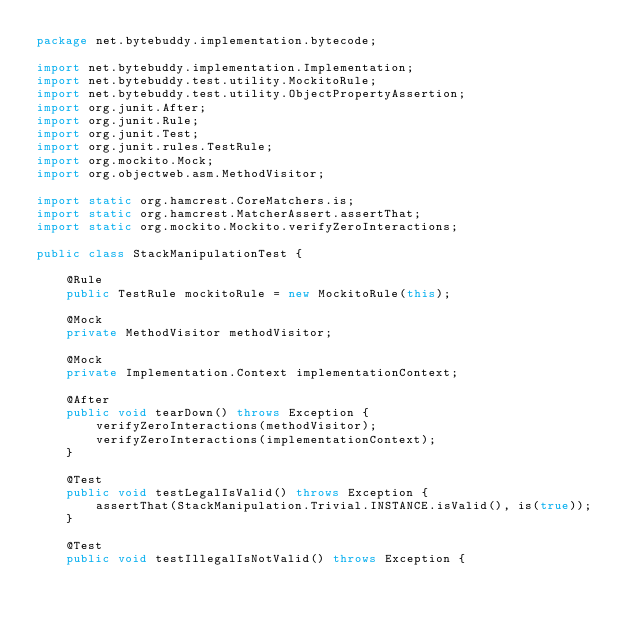<code> <loc_0><loc_0><loc_500><loc_500><_Java_>package net.bytebuddy.implementation.bytecode;

import net.bytebuddy.implementation.Implementation;
import net.bytebuddy.test.utility.MockitoRule;
import net.bytebuddy.test.utility.ObjectPropertyAssertion;
import org.junit.After;
import org.junit.Rule;
import org.junit.Test;
import org.junit.rules.TestRule;
import org.mockito.Mock;
import org.objectweb.asm.MethodVisitor;

import static org.hamcrest.CoreMatchers.is;
import static org.hamcrest.MatcherAssert.assertThat;
import static org.mockito.Mockito.verifyZeroInteractions;

public class StackManipulationTest {

    @Rule
    public TestRule mockitoRule = new MockitoRule(this);

    @Mock
    private MethodVisitor methodVisitor;

    @Mock
    private Implementation.Context implementationContext;

    @After
    public void tearDown() throws Exception {
        verifyZeroInteractions(methodVisitor);
        verifyZeroInteractions(implementationContext);
    }

    @Test
    public void testLegalIsValid() throws Exception {
        assertThat(StackManipulation.Trivial.INSTANCE.isValid(), is(true));
    }

    @Test
    public void testIllegalIsNotValid() throws Exception {</code> 